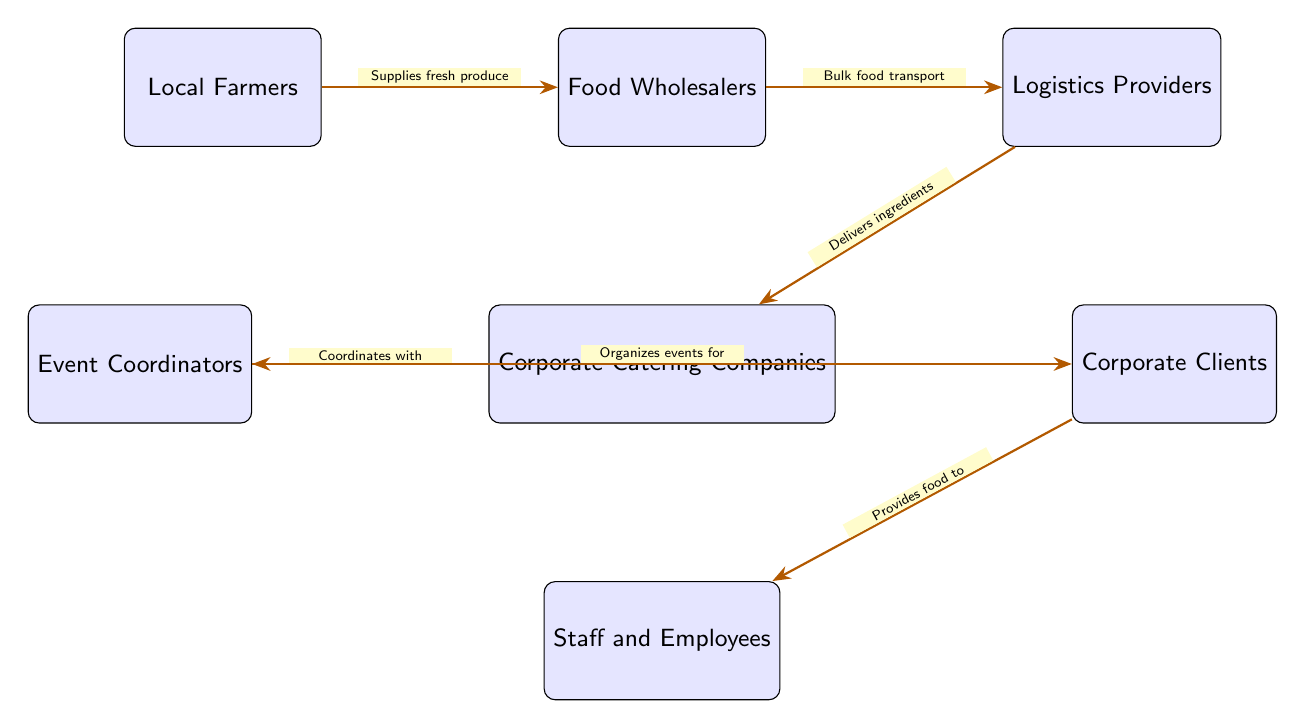What are the first stakeholders in the food chain? The diagram starts with "Local Farmers" as the first node in the food chain. This is represented at the far left of the diagram.
Answer: Local Farmers What role do Food Wholesalers play? Food Wholesalers are depicted as receiving supplies from Local Farmers and are responsible for bulk food transport, connecting them to Logistics Providers.
Answer: Bulk food transport How many total nodes are present in the diagram? By counting all of the individual stakeholders represented as boxes, I find there are seven nodes in total: Local Farmers, Food Wholesalers, Logistics Providers, Corporate Catering Companies, Event Coordinators, Corporate Clients, and Staff and Employees.
Answer: 7 Who coordinates with Corporate Catering Companies? The diagram indicates that "Event Coordinators" are the stakeholders that coordinate with Corporate Catering Companies, which is shown in the connections between their respective nodes.
Answer: Event Coordinators What is the final step in the food chain? The last arrow in the diagram flows from Corporate Clients to Staff and Employees, indicating that the final step in this food chain is providing food to the Staff and Employees.
Answer: Provides food to Describe the flow of ingredients from Local Farmers to Staff and Employees. The flow begins with Local Farmers supplying fresh produce to Food Wholesalers. Next, Food Wholesalers transport bulk food to Logistics Providers, who then deliver ingredients to Corporate Catering Companies. These companies coordinate with Event Coordinators, who then organize events for Corporate Clients. Finally, food is provided to Staff and Employees.
Answer: Local Farmers → Food Wholesalers → Logistics Providers → Corporate Catering Companies → Event Coordinators → Corporate Clients → Staff and Employees Which stakeholders are directly connected to Corporate Catering Companies? Corporate Catering Companies are directly connected to Event Coordinators on the left and Logistics Providers above, marking interactions with these two stakeholders.
Answer: Event Coordinators, Logistics Providers How do Corporate Clients receive food? According to the diagram, Corporate Clients receive food from Corporate Catering Companies, illustrating the service provided directly to them.
Answer: Provides food to 